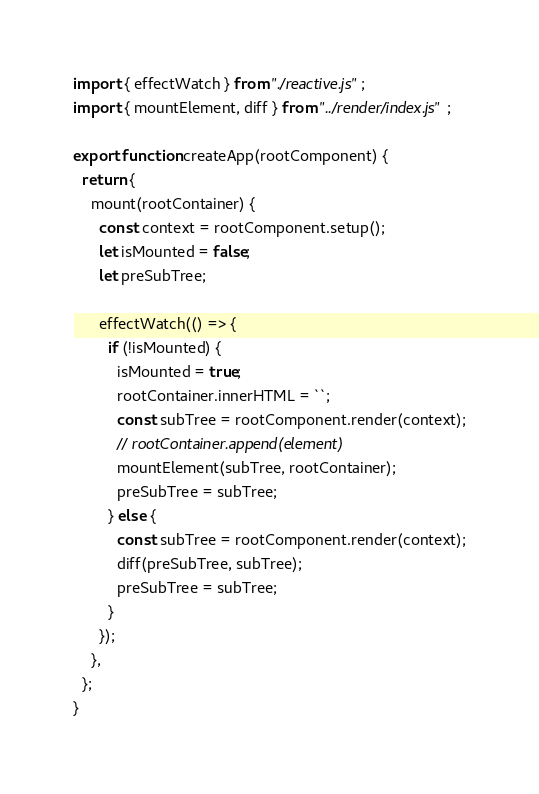<code> <loc_0><loc_0><loc_500><loc_500><_JavaScript_>import { effectWatch } from "./reactive.js";
import { mountElement, diff } from "../render/index.js";

export function createApp(rootComponent) {
  return {
    mount(rootContainer) {
      const context = rootComponent.setup();
      let isMounted = false;
      let preSubTree;

      effectWatch(() => {
        if (!isMounted) {
          isMounted = true;
          rootContainer.innerHTML = ``;
          const subTree = rootComponent.render(context);
          // rootContainer.append(element)
          mountElement(subTree, rootContainer);
          preSubTree = subTree;
        } else {
          const subTree = rootComponent.render(context);
          diff(preSubTree, subTree);
          preSubTree = subTree;
        }
      });
    },
  };
}
</code> 